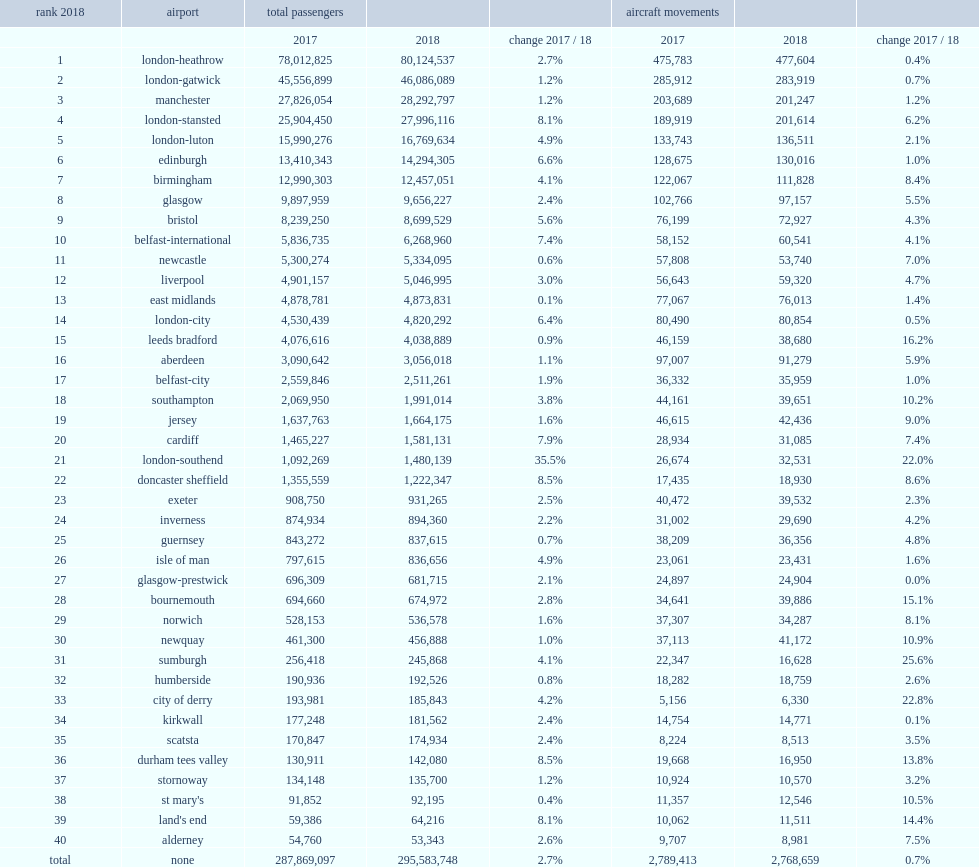What was the rank of liverpool airport in the uk? 12.0. 